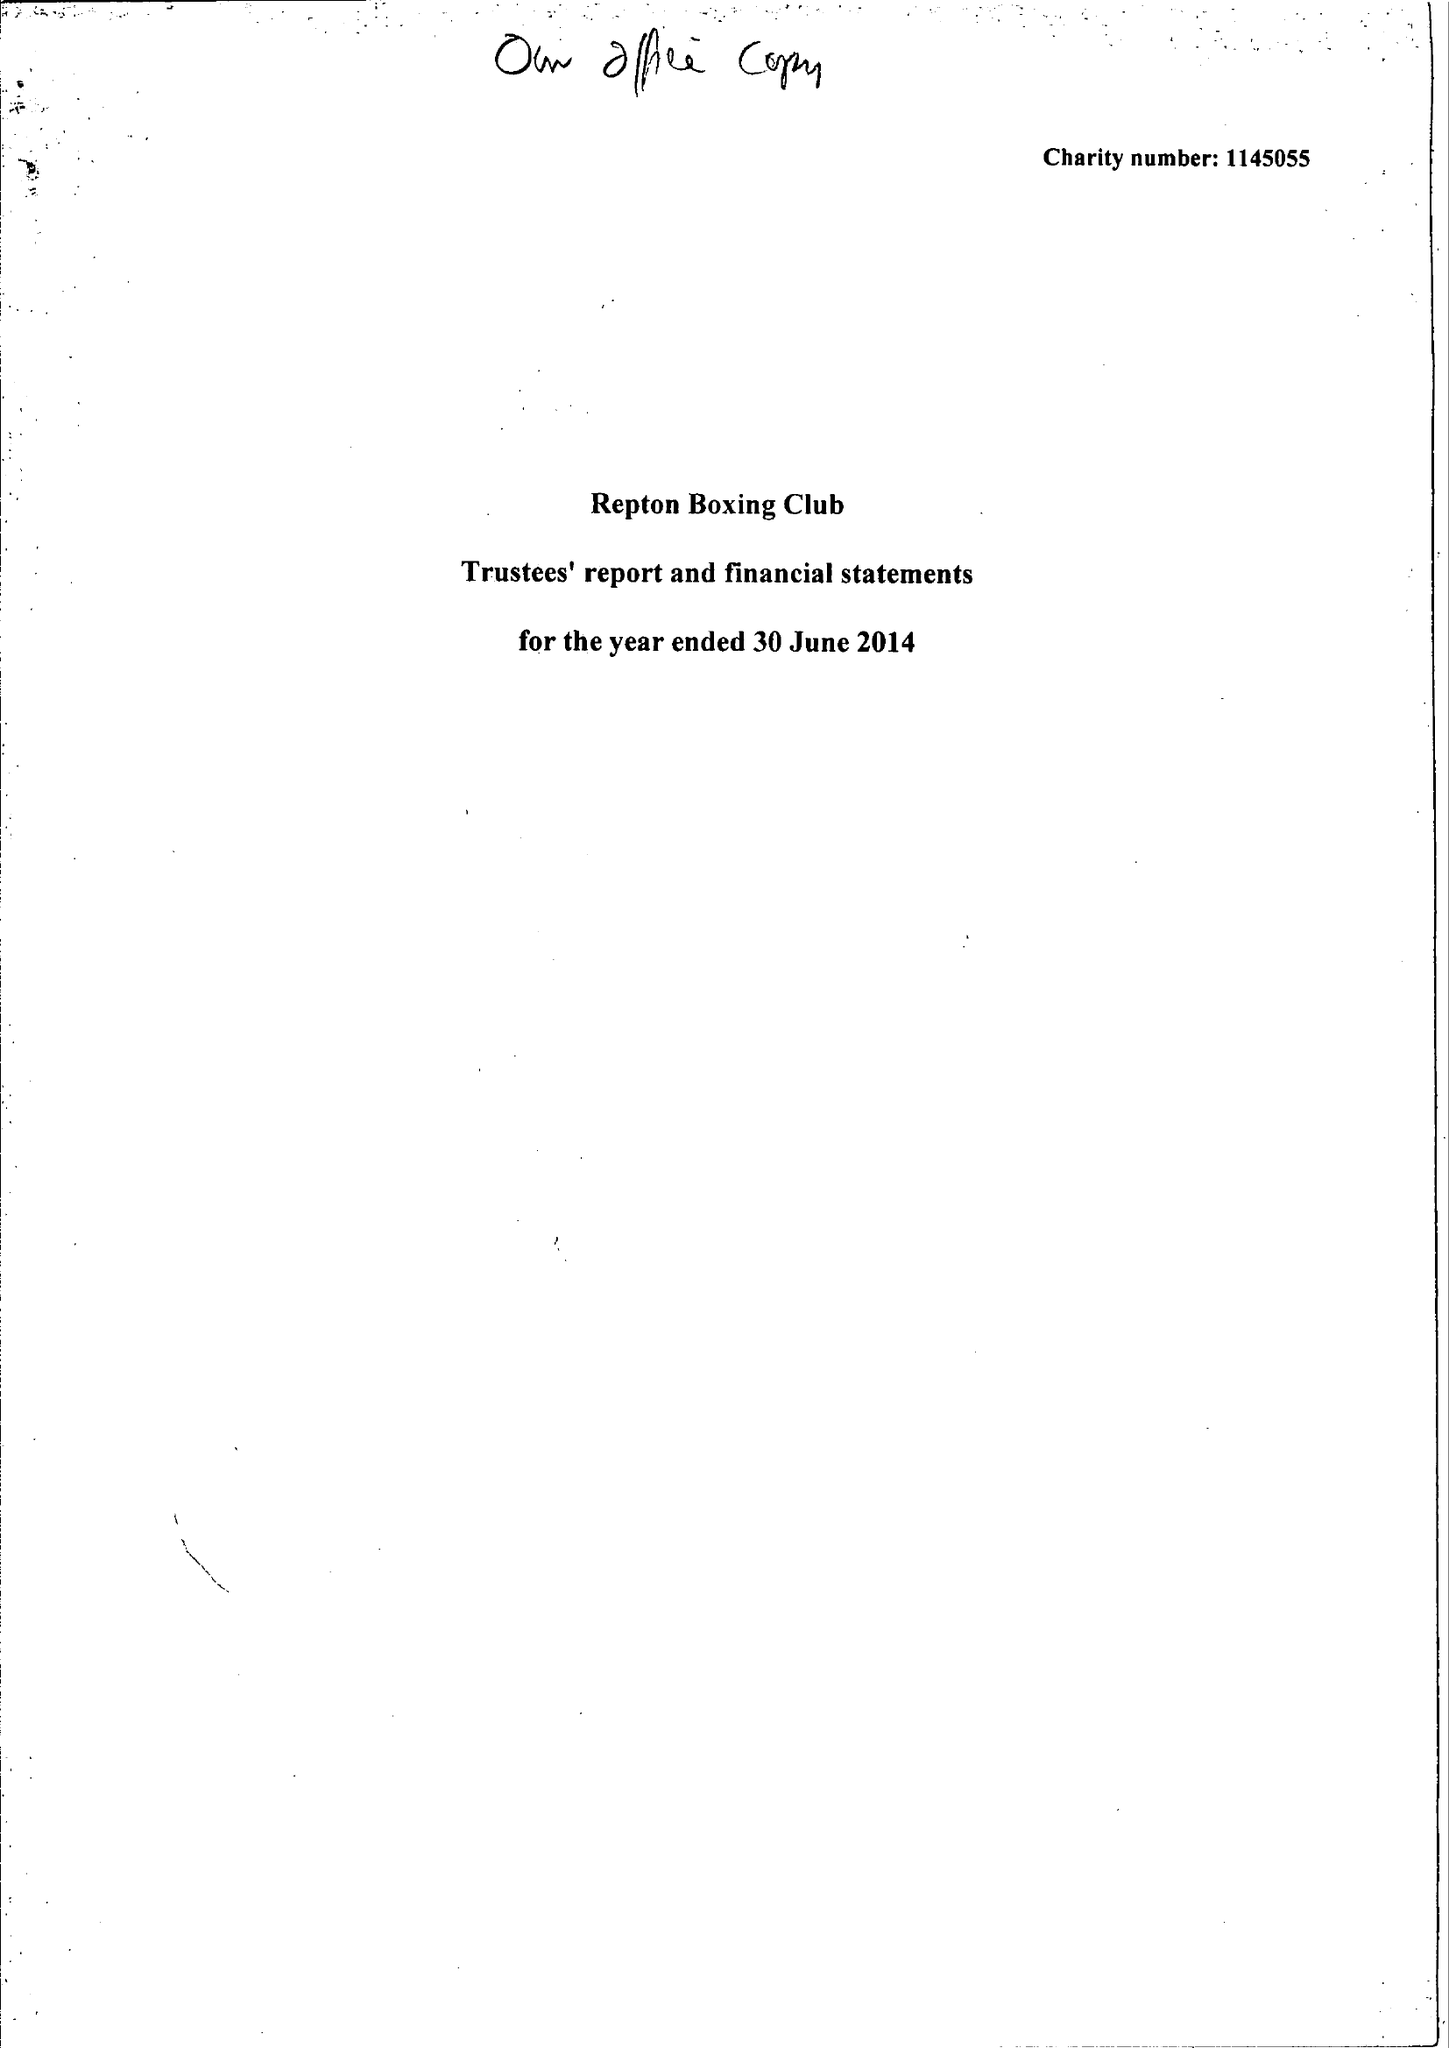What is the value for the charity_number?
Answer the question using a single word or phrase. 1145055 